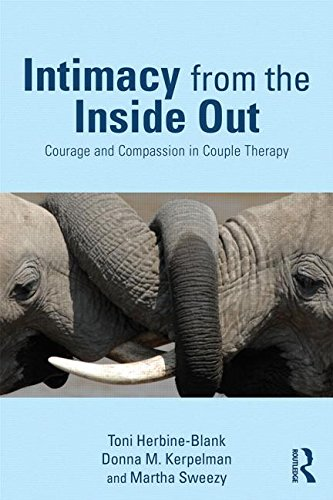Is this book related to Reference? No, this book is not a reference text; it is rather a specialized therapy guide for couple counselors and therapists focusing on intimacy issues. 